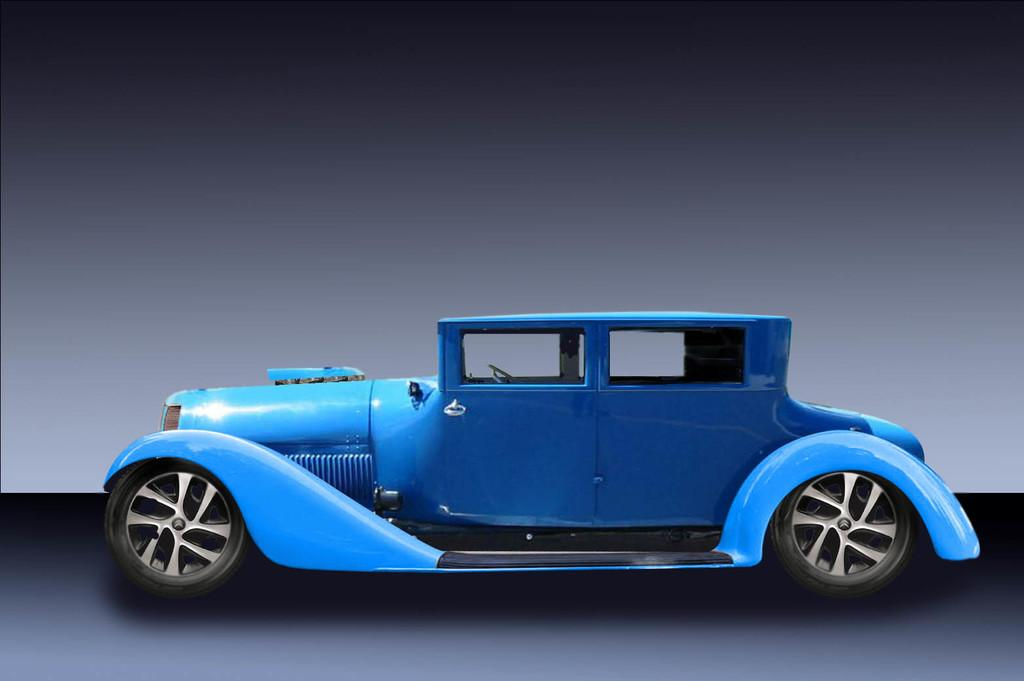What color is the car in the image? The car in the image is blue. What is at the bottom of the image? There is a floor at the bottom of the image. What color is the wall in the background of the image? The wall in the background of the image is gray. Can you tell if the image has been altered or edited? Yes, the image appears to be edited. How does the feeling of love affect the salt content in the image? There is no salt or reference to love in the image; it features a blue car, a floor, and a gray wall. 